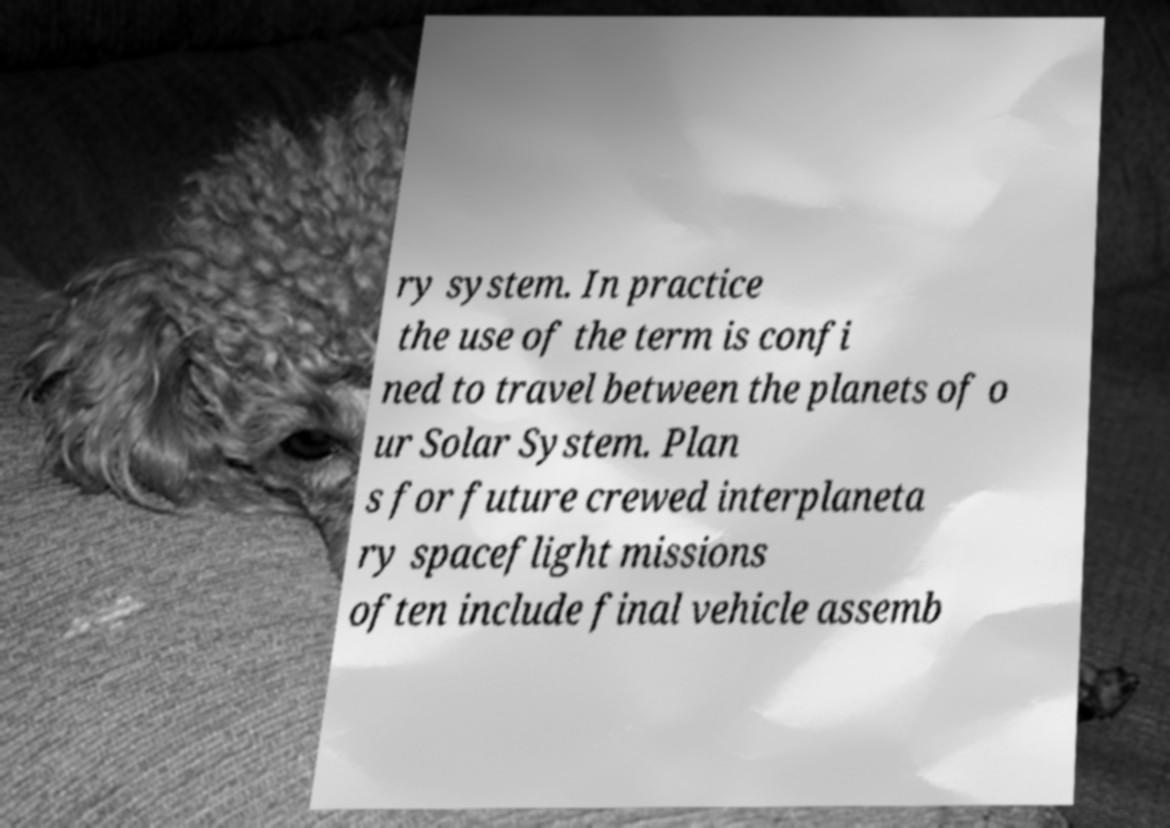Can you accurately transcribe the text from the provided image for me? ry system. In practice the use of the term is confi ned to travel between the planets of o ur Solar System. Plan s for future crewed interplaneta ry spaceflight missions often include final vehicle assemb 